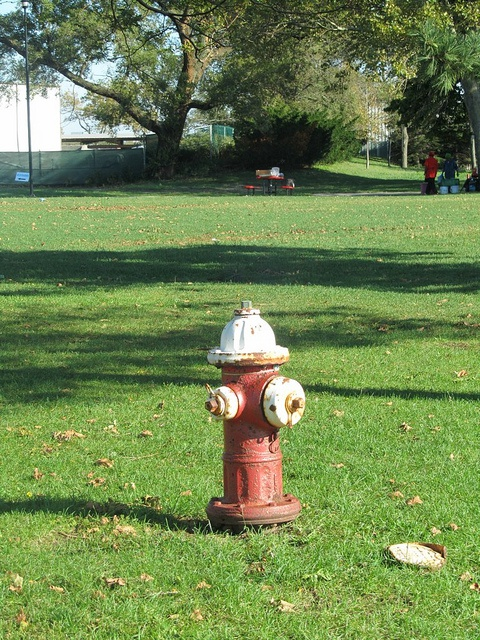Describe the objects in this image and their specific colors. I can see fire hydrant in darkgray, white, maroon, salmon, and olive tones, people in darkgray, black, maroon, brown, and darkgreen tones, people in darkgray and black tones, and people in darkgray, black, maroon, gray, and purple tones in this image. 